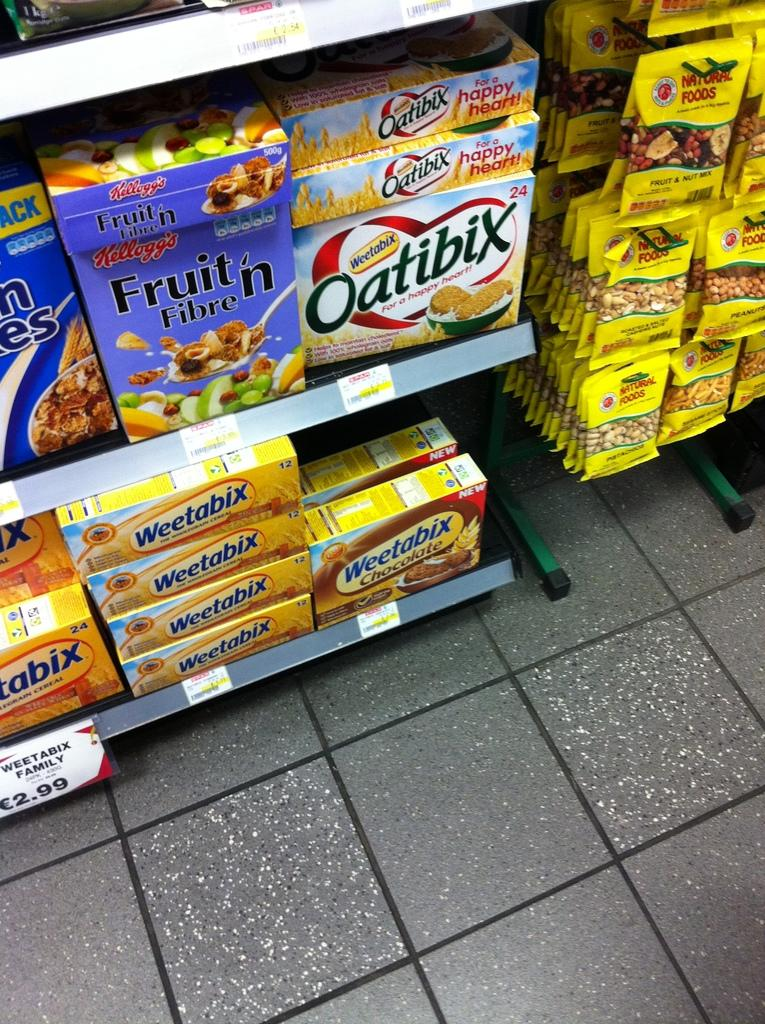<image>
Provide a brief description of the given image. Store selling Weetbix on the bottom of the shelf for $2.99 